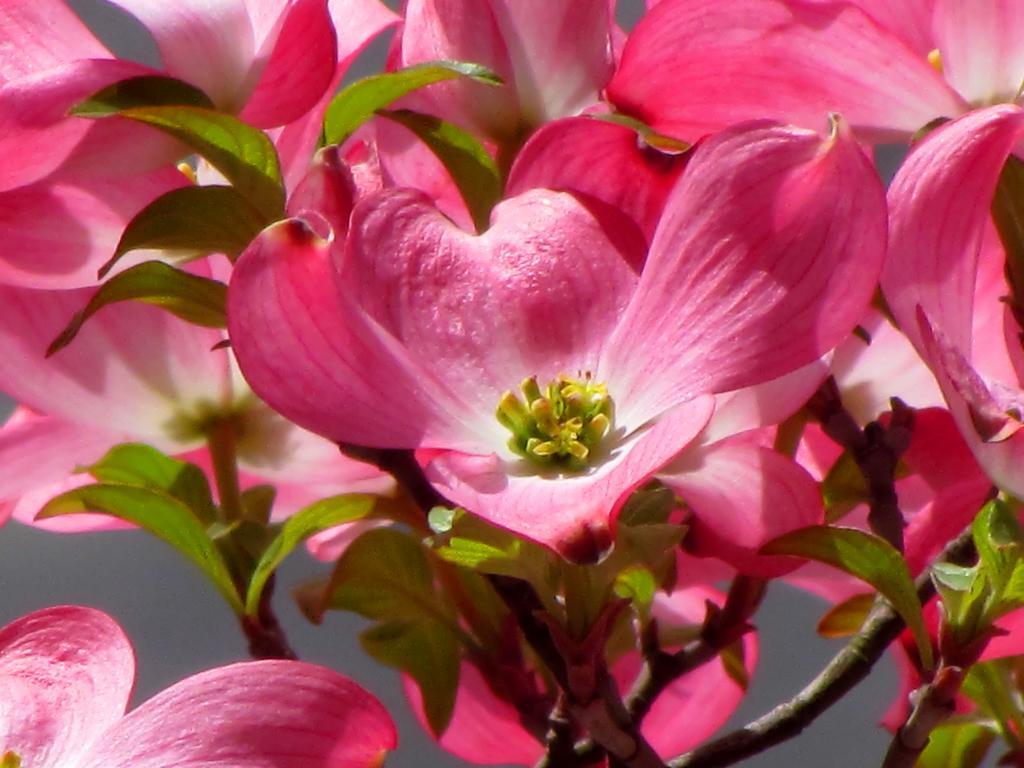Could you give a brief overview of what you see in this image? Here in this picture we can see flowers present on a plant over there and in the middle we can see pollen grains present on the flower over there. 